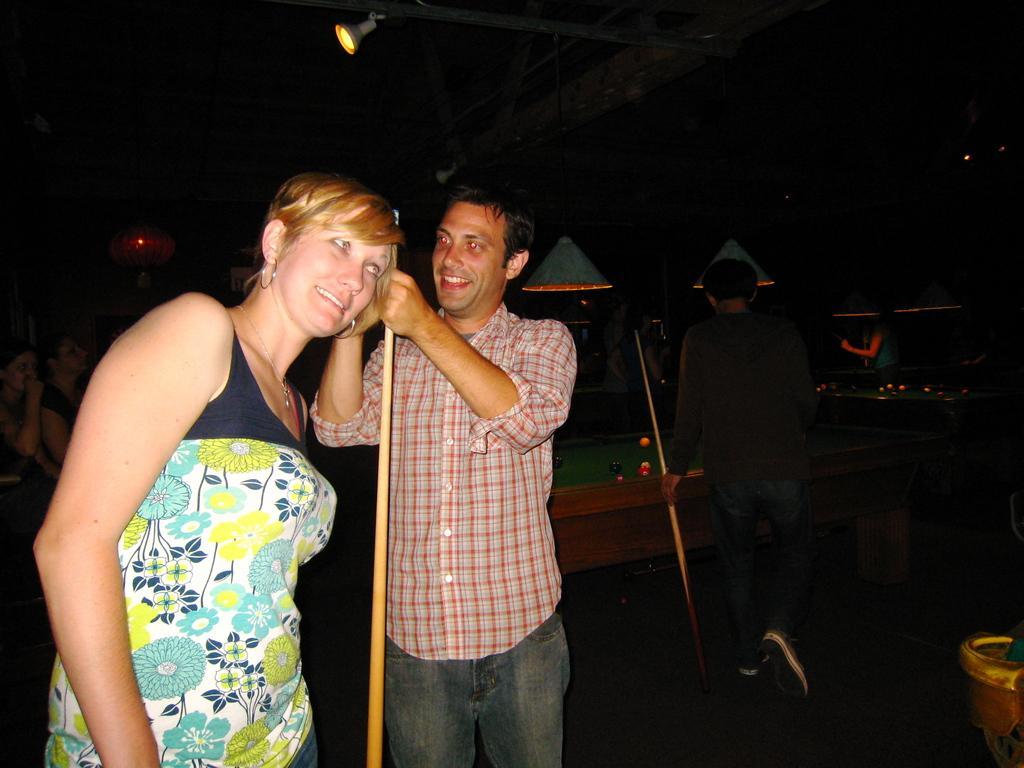Can you describe this image briefly? The person wearing red shirt is holding a snooker stick and there is another woman standing beside him and there is a snooker table and a person in the background. 